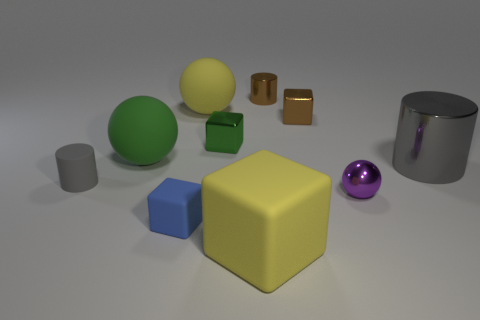There is a big cylinder; is it the same color as the big rubber object behind the tiny brown shiny block?
Your response must be concise. No. There is a large object that is both in front of the tiny brown shiny block and on the left side of the yellow block; what shape is it?
Your answer should be very brief. Sphere. How many small shiny cylinders are there?
Your response must be concise. 1. What is the shape of the rubber thing that is the same color as the large cylinder?
Provide a short and direct response. Cylinder. There is a rubber thing that is the same shape as the big gray shiny thing; what size is it?
Provide a succinct answer. Small. There is a big object that is behind the tiny brown cube; does it have the same shape as the gray shiny object?
Your answer should be compact. No. What is the color of the metal cylinder that is in front of the brown cylinder?
Your answer should be compact. Gray. What number of other objects are there of the same size as the gray matte thing?
Ensure brevity in your answer.  5. Is there anything else that is the same shape as the blue object?
Ensure brevity in your answer.  Yes. Are there the same number of gray metallic things that are in front of the small gray matte object and small matte objects?
Your response must be concise. No. 